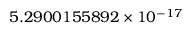Convert formula to latex. <formula><loc_0><loc_0><loc_500><loc_500>5 . 2 9 0 0 1 5 5 8 9 2 \times 1 0 ^ { - 1 7 }</formula> 